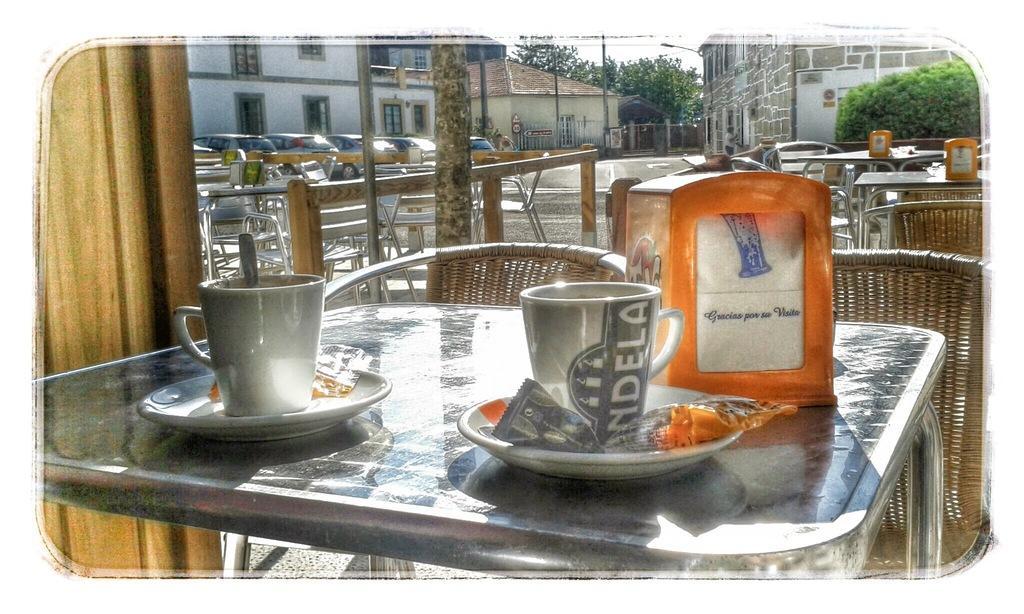How would you summarize this image in a sentence or two? In this image, we can see so many tables, chairs. On top of the table, items are placed on it. On left side, we can see wooden wall. And the background, there is a house, buildings. We can see plants, ski, poles. Here we can see vehicles are parked and there is a road. 